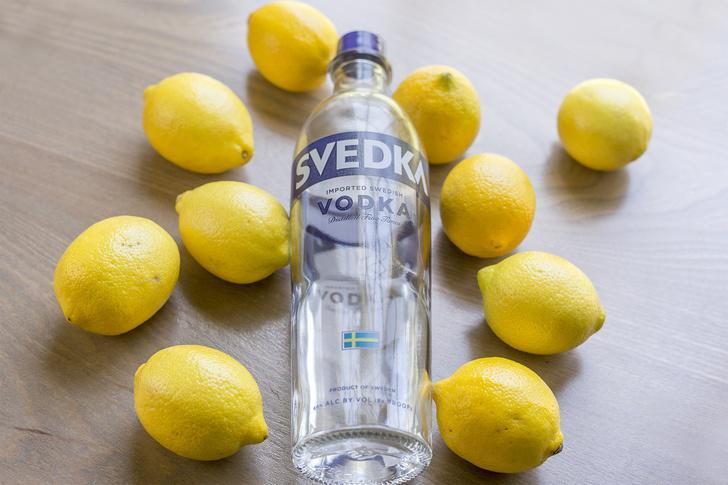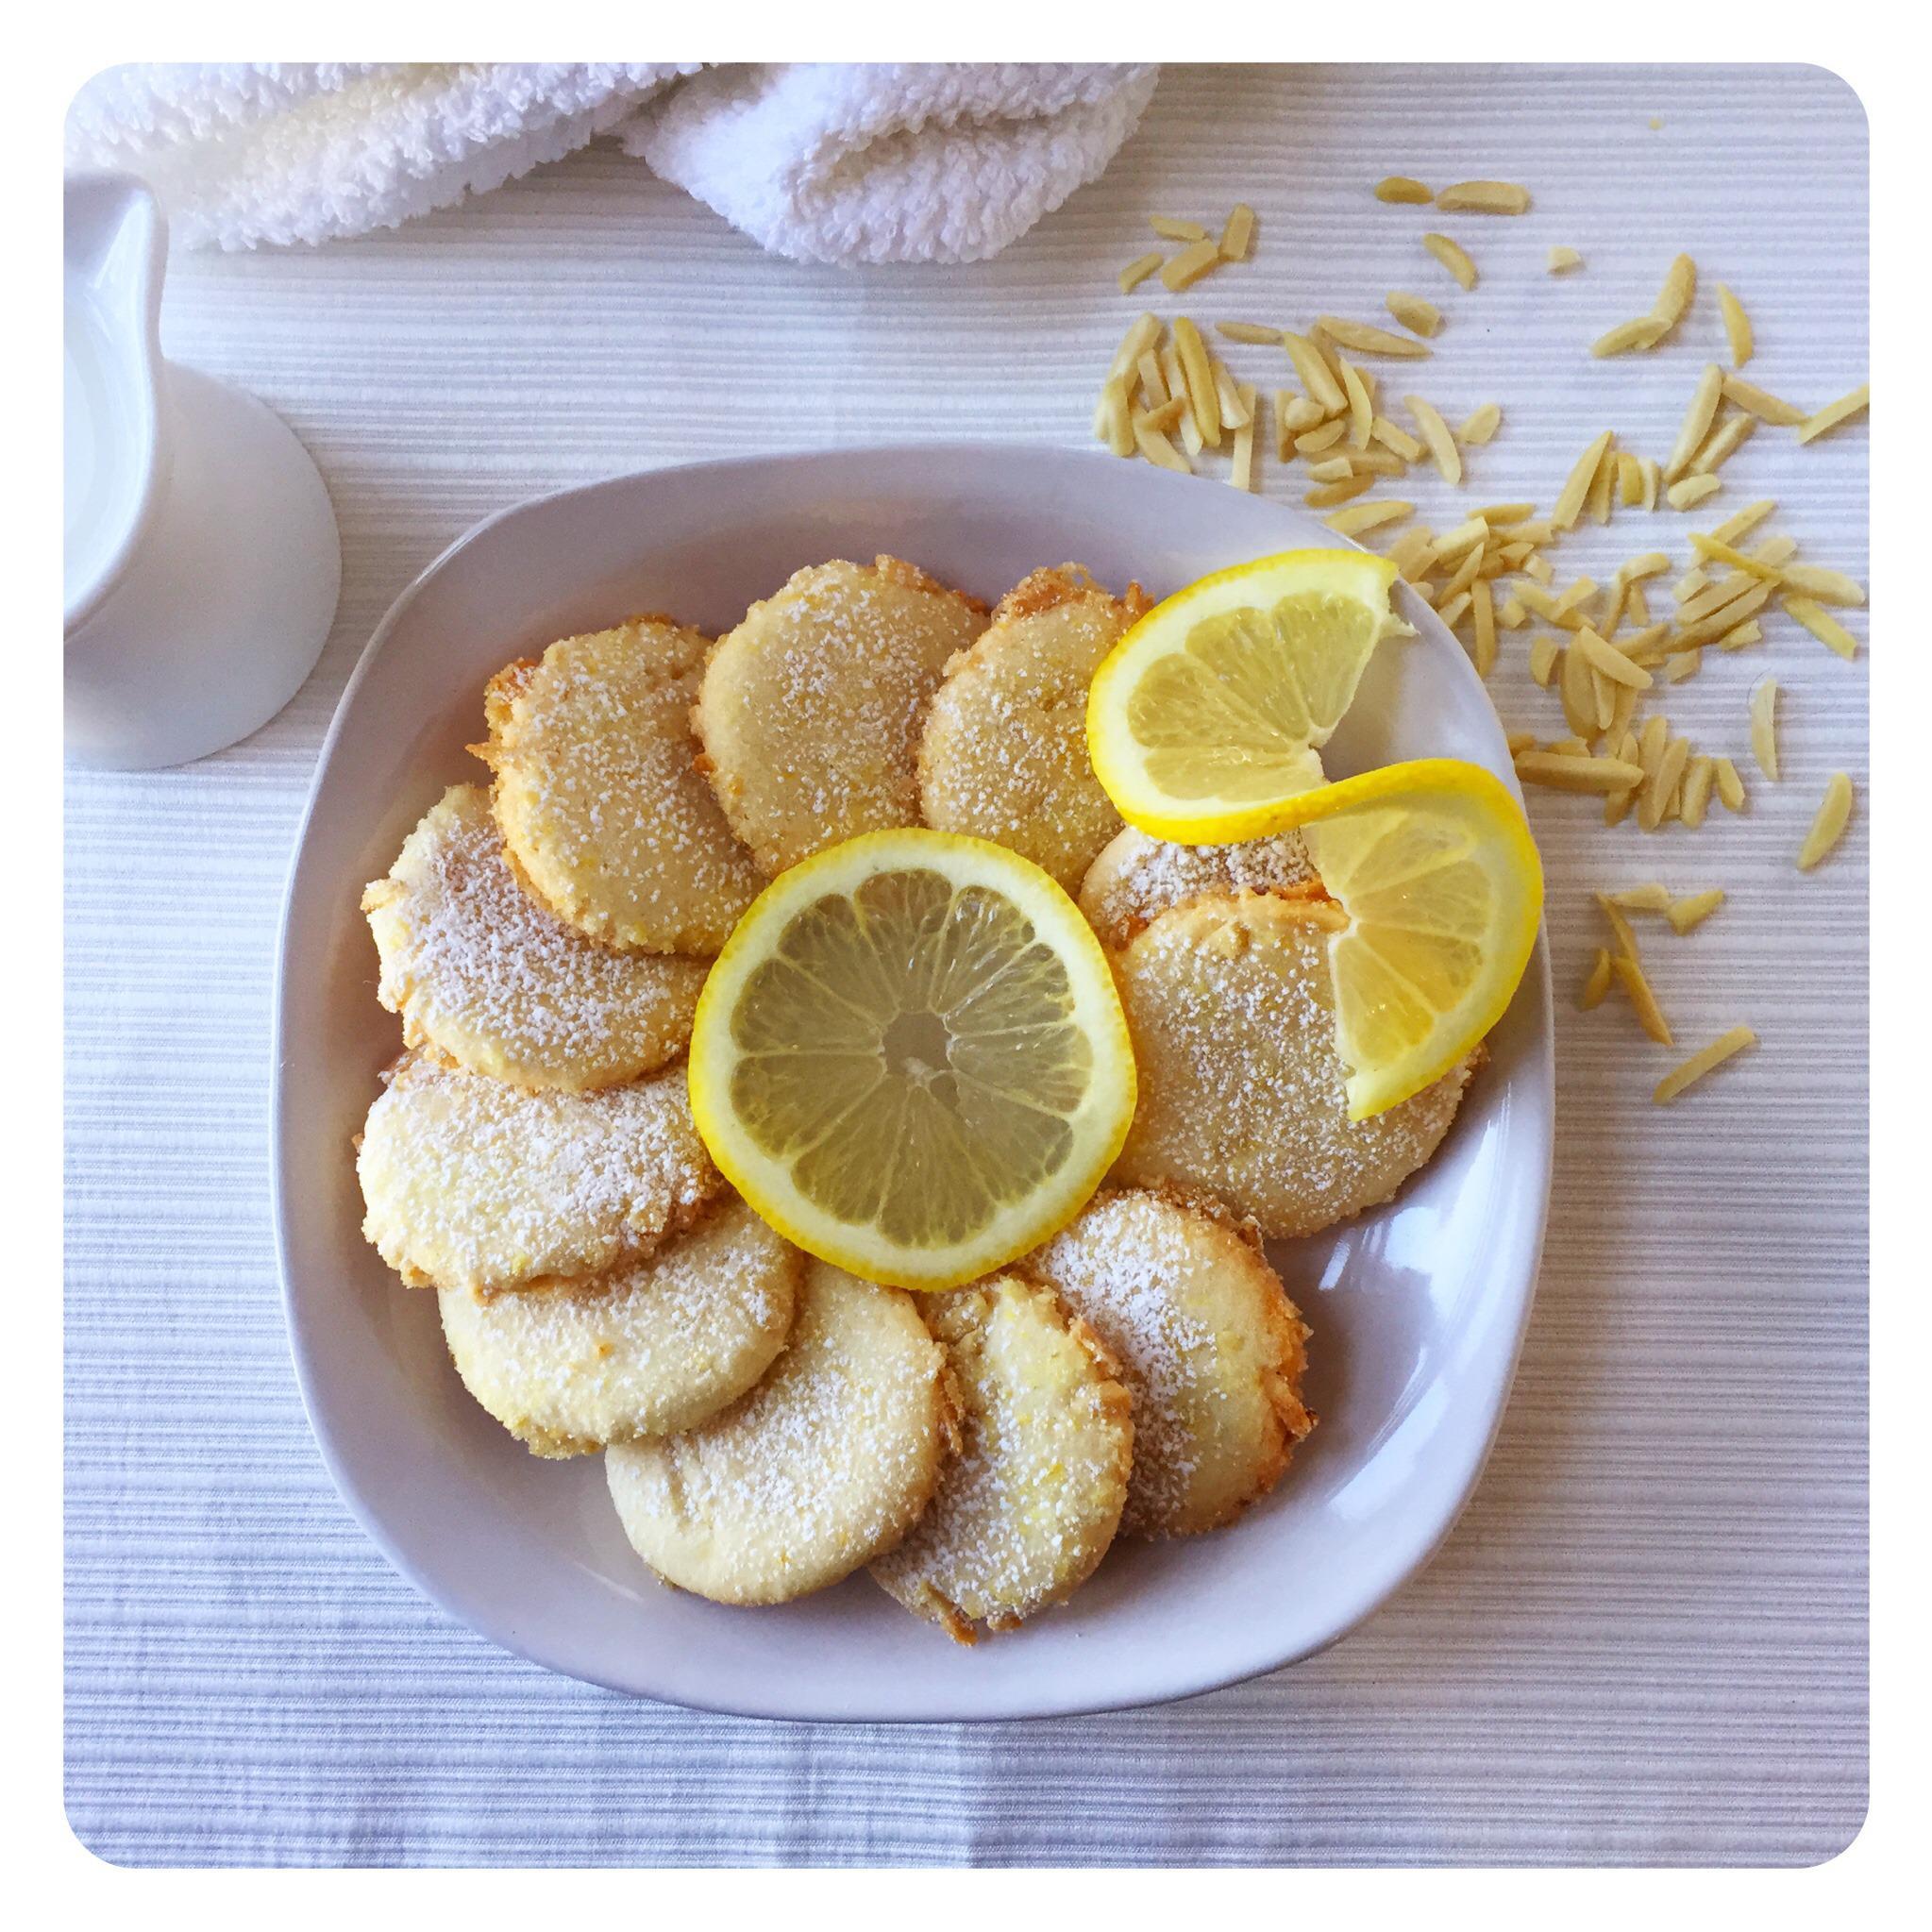The first image is the image on the left, the second image is the image on the right. Assess this claim about the two images: "One spoon is resting in a bowl of food containing lemons.". Correct or not? Answer yes or no. No. The first image is the image on the left, the second image is the image on the right. Given the left and right images, does the statement "One image features a scattered display on a painted wood surface that includes whole lemons, cut lemons, and green leaves." hold true? Answer yes or no. No. 